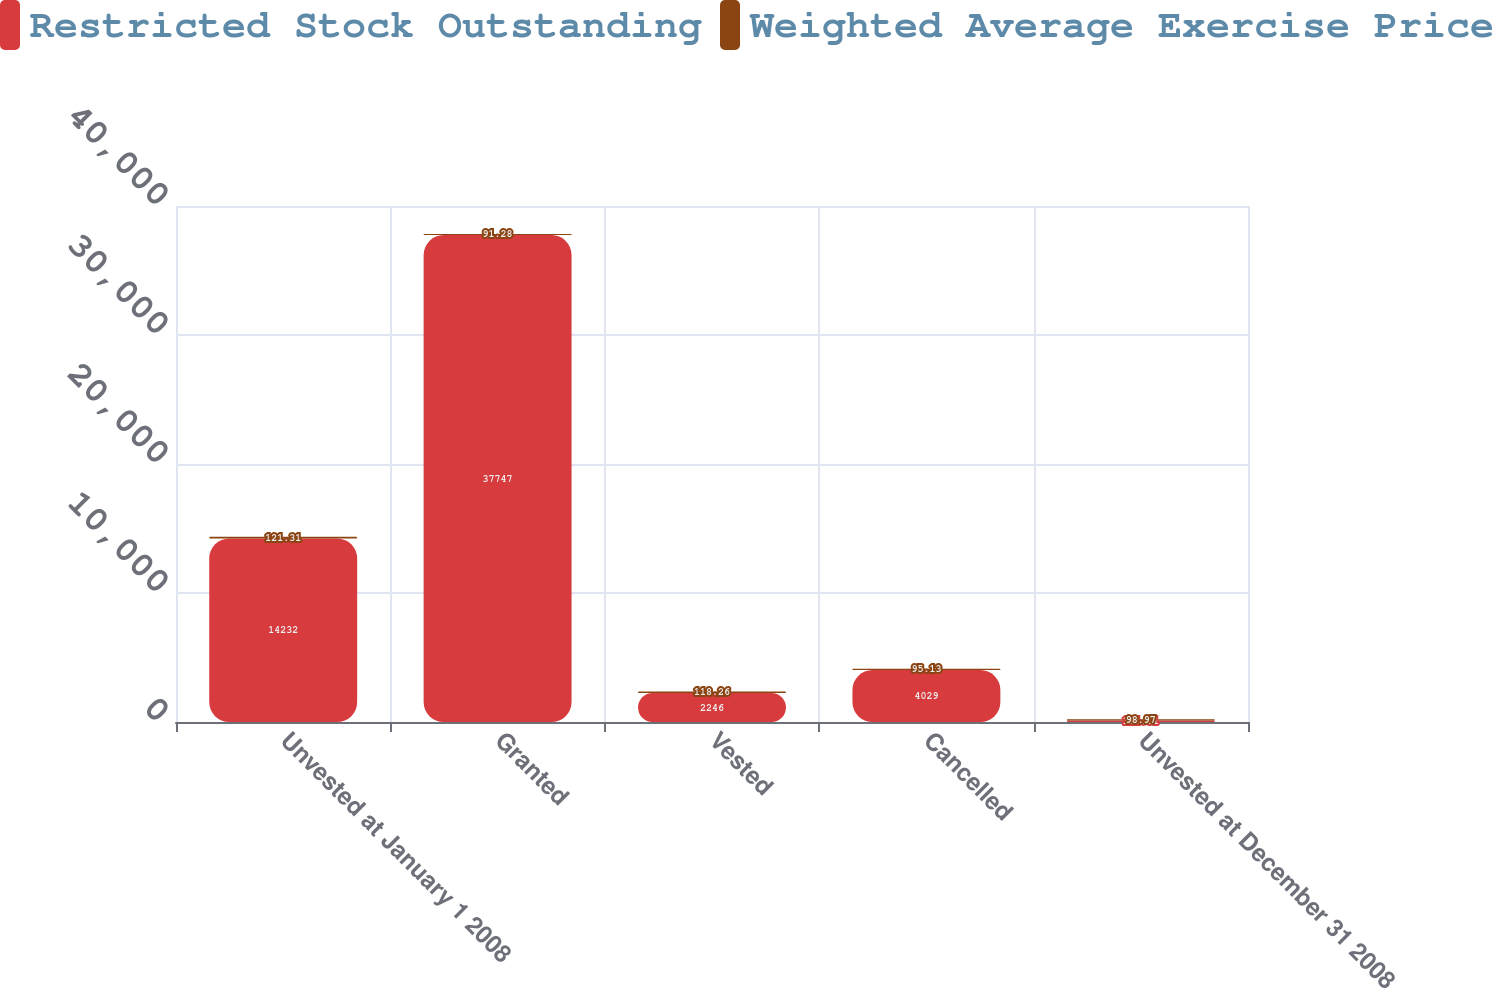Convert chart. <chart><loc_0><loc_0><loc_500><loc_500><stacked_bar_chart><ecel><fcel>Unvested at January 1 2008<fcel>Granted<fcel>Vested<fcel>Cancelled<fcel>Unvested at December 31 2008<nl><fcel>Restricted Stock Outstanding<fcel>14232<fcel>37747<fcel>2246<fcel>4029<fcel>121.31<nl><fcel>Weighted Average Exercise Price<fcel>121.31<fcel>91.28<fcel>118.26<fcel>95.13<fcel>98.97<nl></chart> 